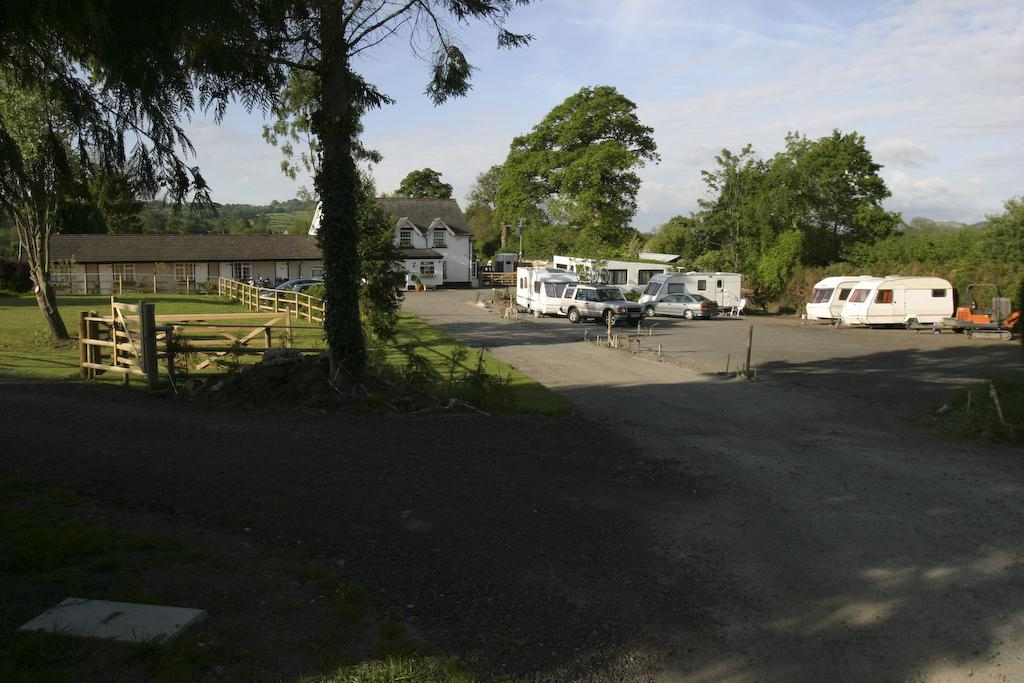What type of structure is visible in the image? There is a building with windows in the image. What natural elements can be seen in the image? There are trees and grass in the image. What man-made objects are present in the image? There are cars and a road in the image. What additional objects can be found in the image? There are sticks in the image. What effect does the tree have on the rub in the image? There is no tree or rub present in the image, so this question cannot be answered. 